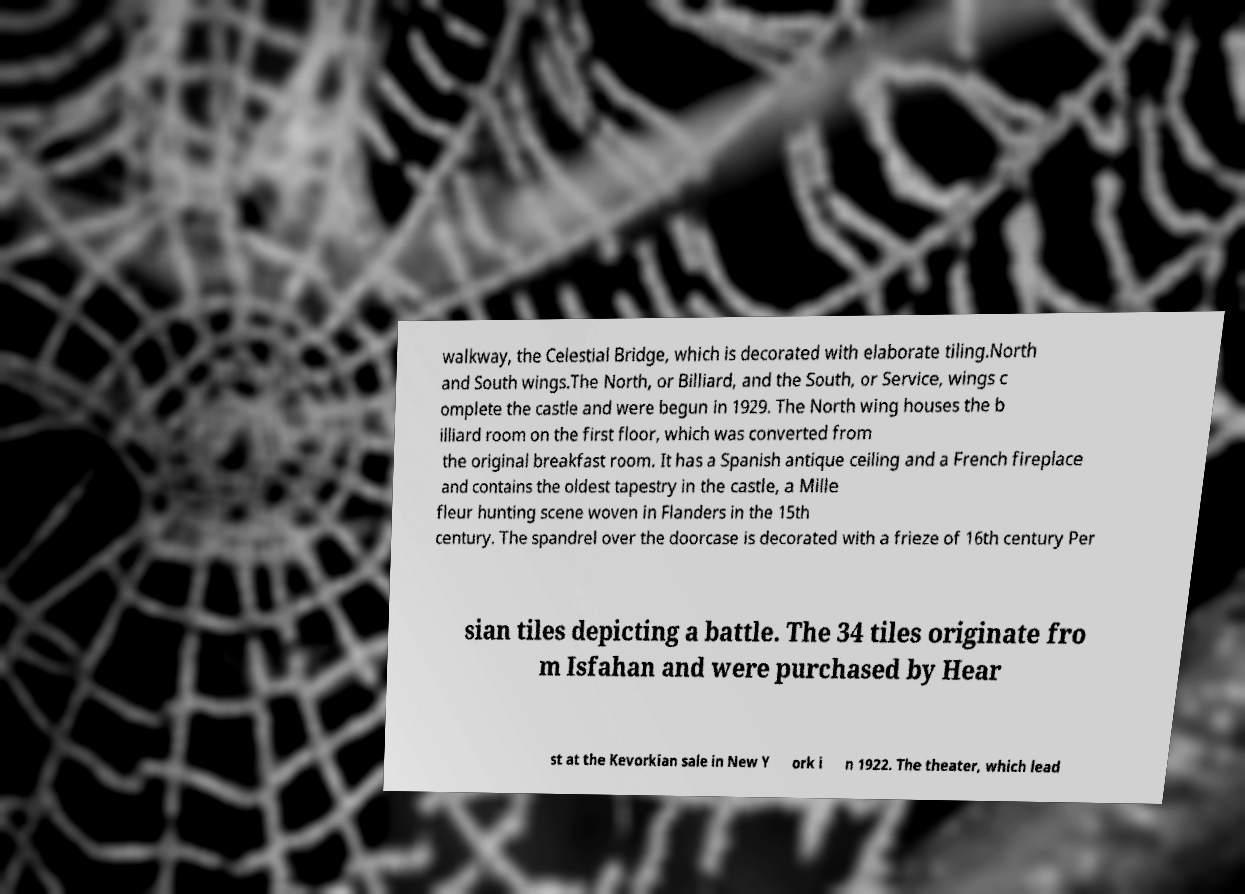What messages or text are displayed in this image? I need them in a readable, typed format. walkway, the Celestial Bridge, which is decorated with elaborate tiling.North and South wings.The North, or Billiard, and the South, or Service, wings c omplete the castle and were begun in 1929. The North wing houses the b illiard room on the first floor, which was converted from the original breakfast room. It has a Spanish antique ceiling and a French fireplace and contains the oldest tapestry in the castle, a Mille fleur hunting scene woven in Flanders in the 15th century. The spandrel over the doorcase is decorated with a frieze of 16th century Per sian tiles depicting a battle. The 34 tiles originate fro m Isfahan and were purchased by Hear st at the Kevorkian sale in New Y ork i n 1922. The theater, which lead 